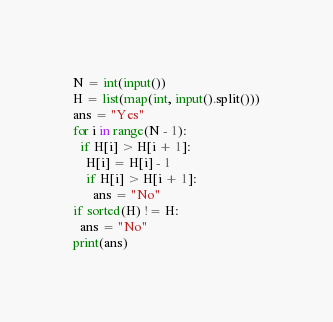<code> <loc_0><loc_0><loc_500><loc_500><_Python_>N = int(input())
H = list(map(int, input().split()))
ans = "Yes"
for i in range(N - 1):
  if H[i] > H[i + 1]:
    H[i] = H[i] - 1
    if H[i] > H[i + 1]:
      ans = "No"
if sorted(H) != H:
  ans = "No"
print(ans)</code> 